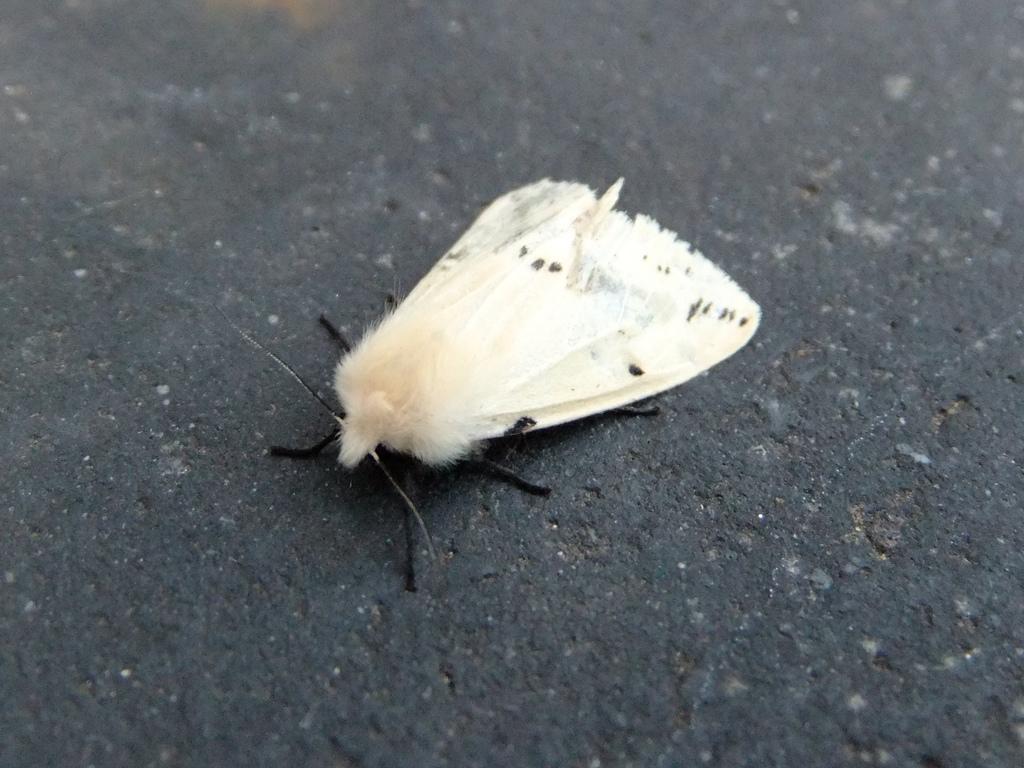Describe this image in one or two sentences. In the center of the picture there is an insect on a black surface. 